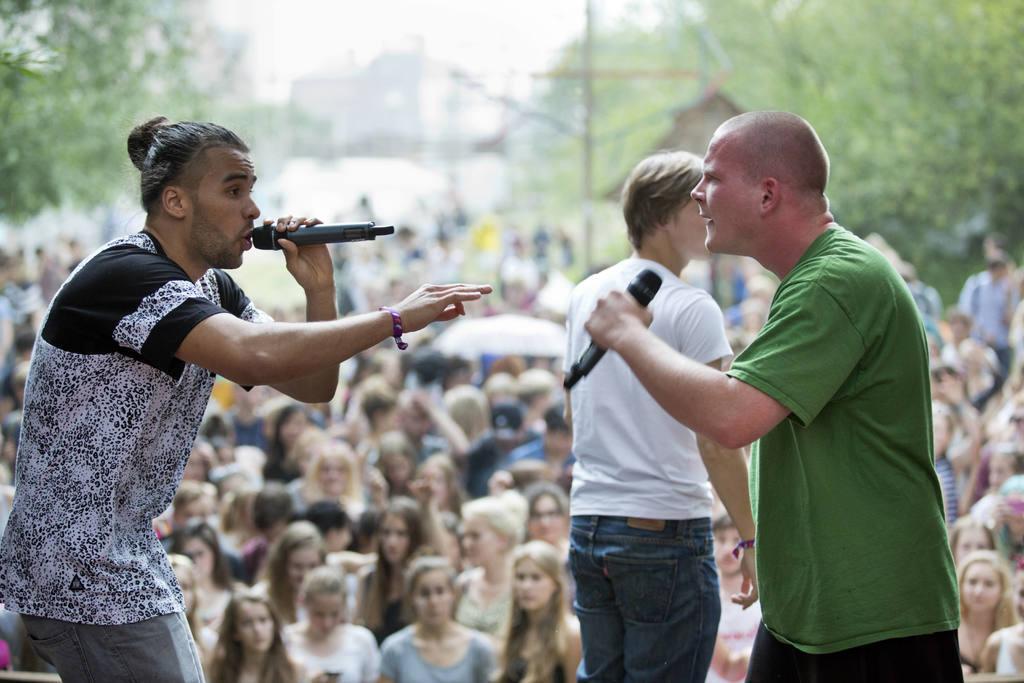How would you summarize this image in a sentence or two? In this image there are three people standing and two are holding mics in their hands, in the background there are people standing and there are trees and it is blurred. 